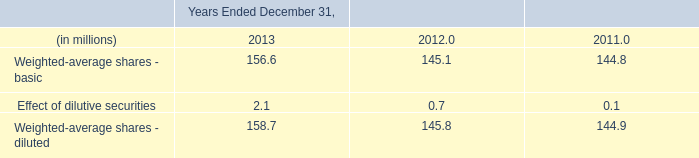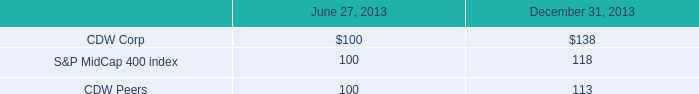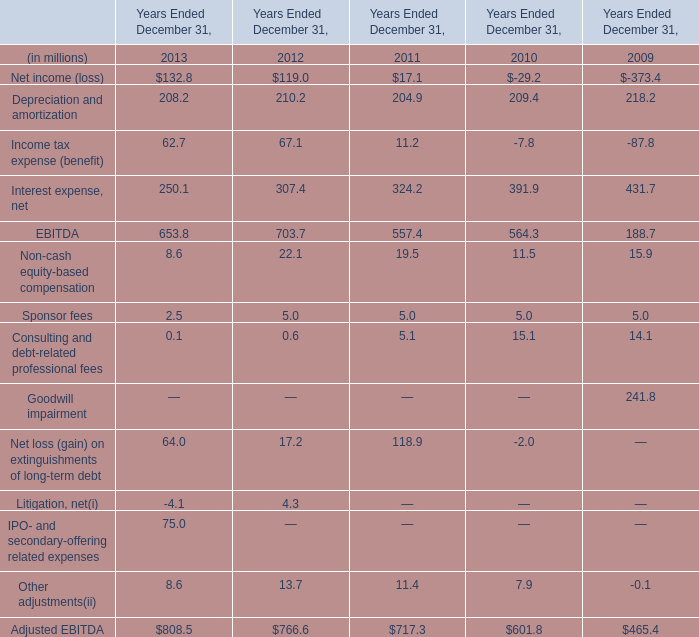Which year is Income tax expense (benefit) the most? 
Answer: 2012. 